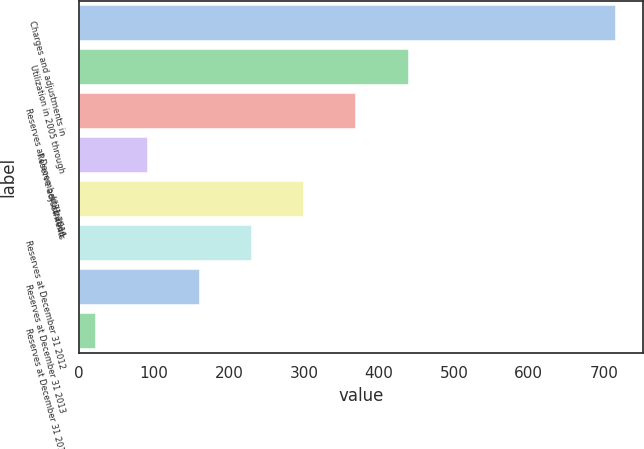Convert chart to OTSL. <chart><loc_0><loc_0><loc_500><loc_500><bar_chart><fcel>Charges and adjustments in<fcel>Utilization in 2005 through<fcel>Reserves at December 31 2011<fcel>Reserve adjustments<fcel>Utilization<fcel>Reserves at December 31 2012<fcel>Reserves at December 31 2013<fcel>Reserves at December 31 2014<nl><fcel>716<fcel>440<fcel>369<fcel>91.4<fcel>299.6<fcel>230.2<fcel>160.8<fcel>22<nl></chart> 